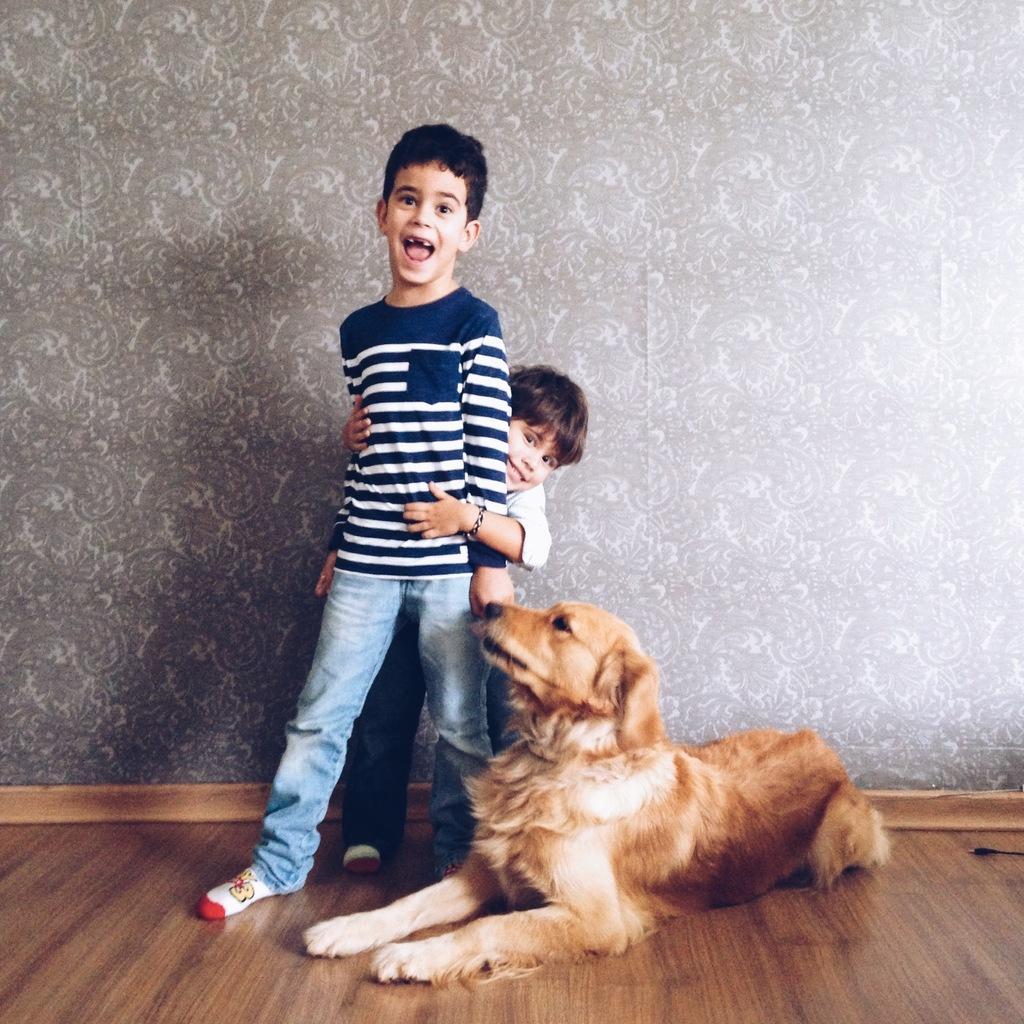Please provide a concise description of this image. In the picture we can see two kids standing together and there is a dog which is resting on ground and in the background of the picture there is a wall. 